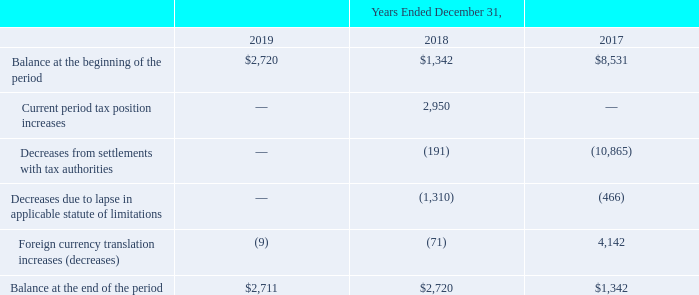During the year ended December 31, 2019, the Company completed a reorganization of certain of its foreign subsidiaries that resulted in the derecognition of the related deferred tax assets for net operating losses which were subject to a valuation allowance. As a result, the Company reduced both its net operating loss deferred tax assets and valuation allowance by approximately $19.7 million.
The Company accrued $2.7 million as of both December 31, 2019 and 2018, excluding penalties and interest, for the liability for unrecognized tax benefits, which was included in “Long-term income tax liabilities” in the accompanying Consolidated Balance Sheets. Had the Company recognized these tax benefits, approximately $2.7 million, along with the related interest and penalties, would have favorably impacted the effective tax rate in both 2019 and 2018. The Company does not anticipate that any of the unrecognized tax benefits will be recognized in the next twelve months.
The Company recognizes interest and penalties related to unrecognized tax benefits in the provision for income taxes. The Company had $1.1 million and $0.6 million accrued for interest and penalties as of December 31, 2019 and 2018, respectively. Of the accrued interest and penalties at December 31, 2019 and 2018, $0.6 million and $0.4 million, respectively, relate to statutory penalties. The amount of interest and penalties, net, included in the provision for income taxes in the accompanying Consolidated Statements of Operations for the years ended December 31, 2019, 2018 and 2017 was $0.4 million, $0.7 million and $(9.5) million, respectively.
The tabular reconciliation of the amounts of unrecognized net tax benefits is presented below (in thousands):
What was the Balance at the end of the period in 2019?
Answer scale should be: thousand. $2,711. What was the Balance at the beginning of the period in 2018?
Answer scale should be: thousand. $1,342. For which years were the tabular reconciliation of the amounts of unrecognized net tax benefits calculated? 2019, 2018, 2017. In which year was the Balance at the end of the period the largest? 2,720>2,711>1,342
Answer: 2018. What was the change in the Balance at the end of the period in 2019 from 2018?
Answer scale should be: thousand. 2,711-2,720
Answer: -9. What was the percentage change in the Balance at the end of the period in 2019 from 2018?
Answer scale should be: percent. (2,711-2,720)/2,720
Answer: -0.33. 